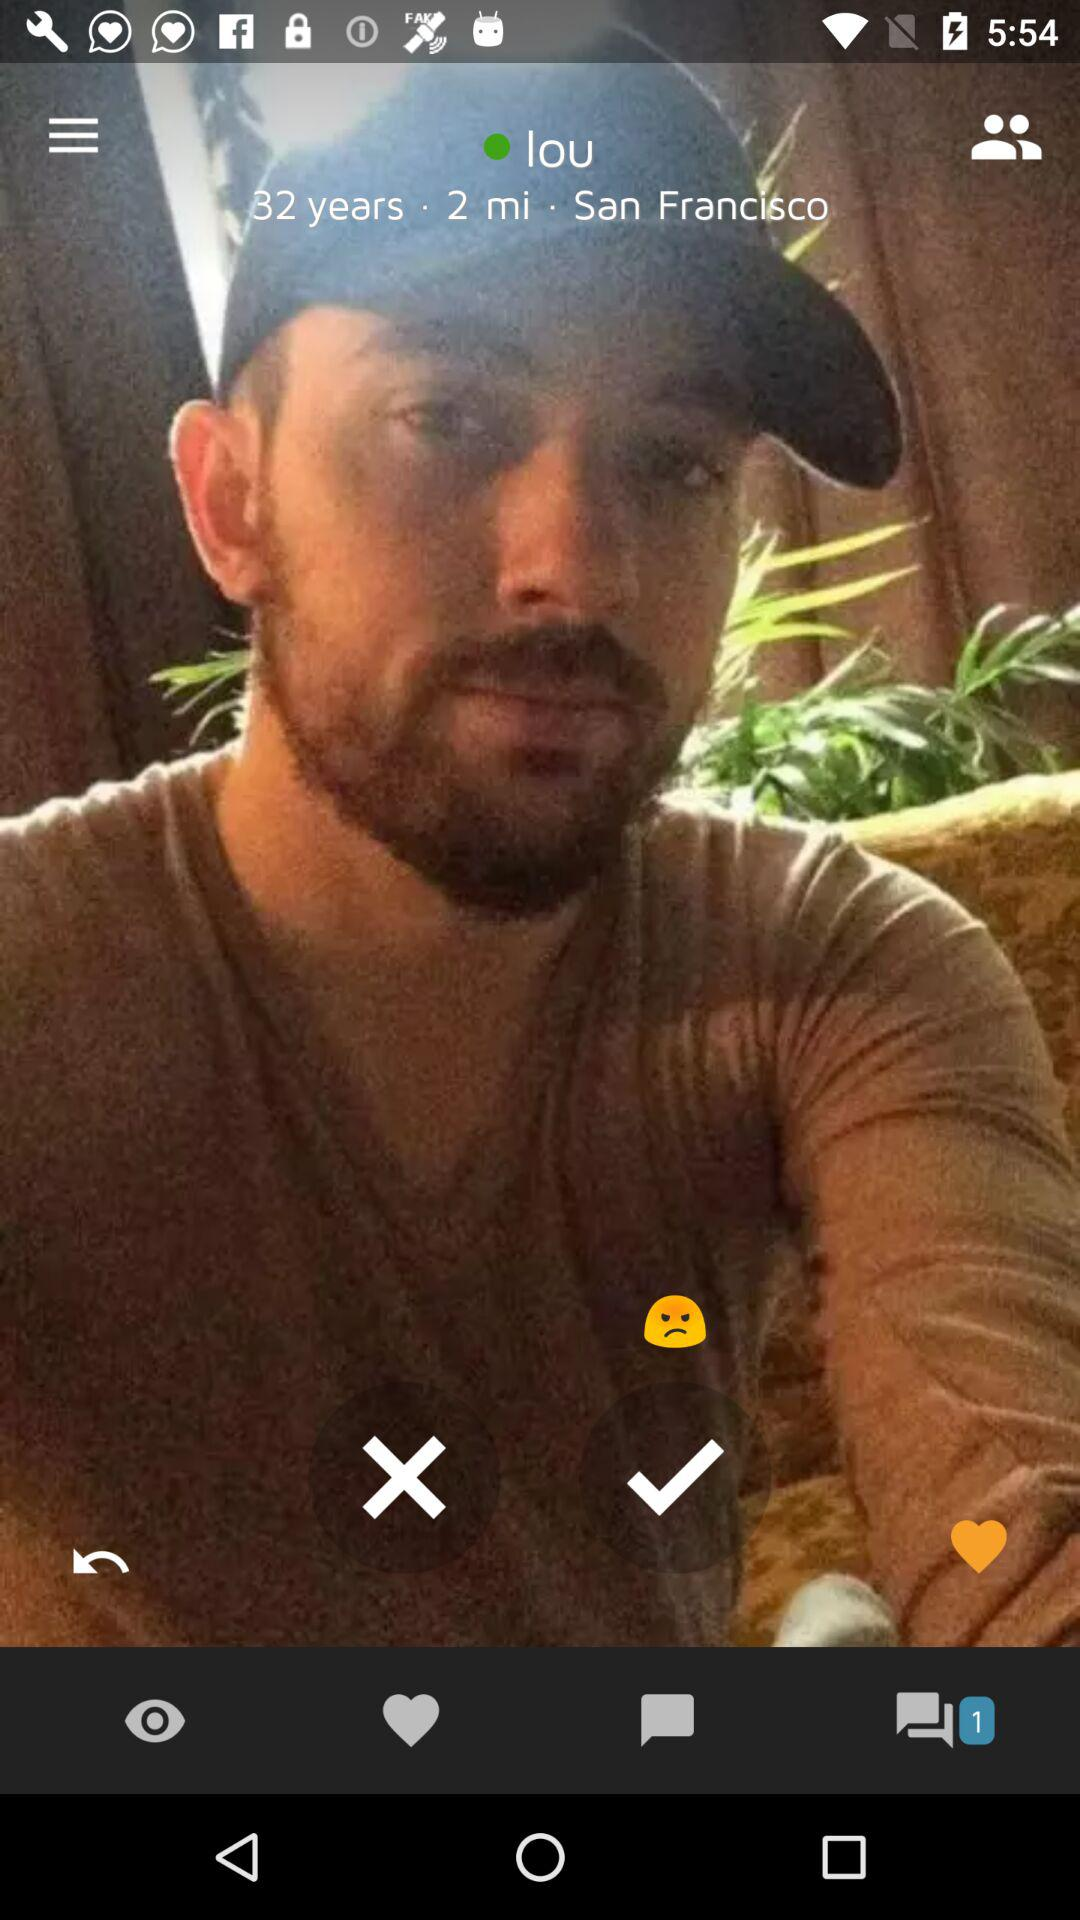What is the name of the person? The name of the person is Lou. 